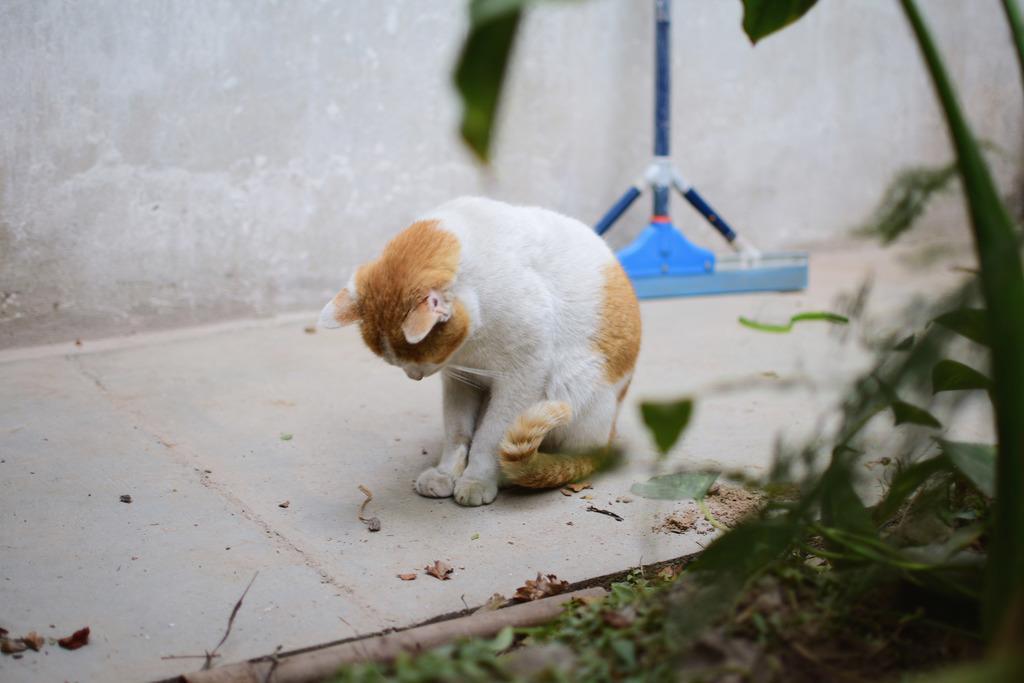Please provide a concise description of this image. This image consists of plants on the right side. There is a cat in the middle. It is in white color. There is a wiper in the middle. It is in blue color. 